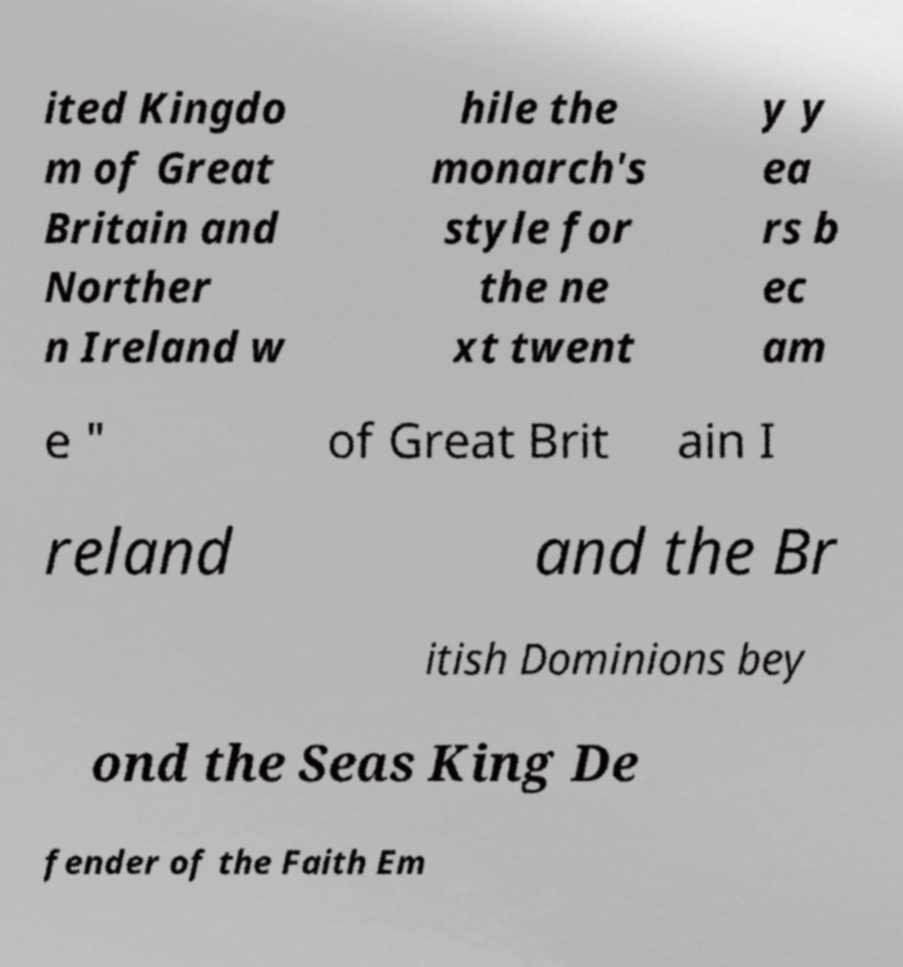Could you extract and type out the text from this image? ited Kingdo m of Great Britain and Norther n Ireland w hile the monarch's style for the ne xt twent y y ea rs b ec am e " of Great Brit ain I reland and the Br itish Dominions bey ond the Seas King De fender of the Faith Em 